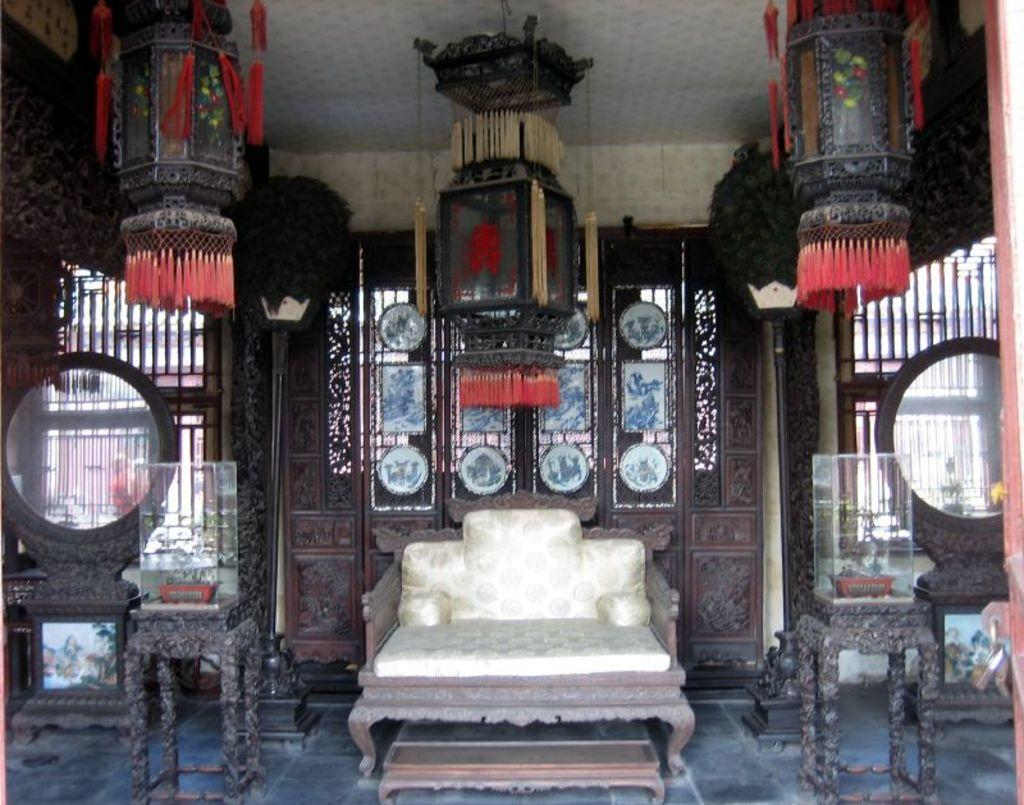What type of furniture is present in the image? There is a couch in the image. What other objects can be seen in the image? There are tables, glass boxes, plants, light poles, lantern lamps, and frames in the image. What architectural feature is visible in the image? There is a designed wooden wall in the image. What can be used for viewing the surroundings in the image? There is a mirror in the image. What can be used for displaying items in the image? The glass boxes can be used for displaying items. What can be used for illuminating the area in the image? The lantern lamps can be used for illuminating the area. What can be used for ventilation and light in the image? There are windows in the image. What is the uppermost part of the structure in the image? There is a roof in the image. What is the weight of the appliance in the image? There is no appliance present in the image. What type of patch can be seen on the couch in the image? There is no patch visible on the couch in the image. 